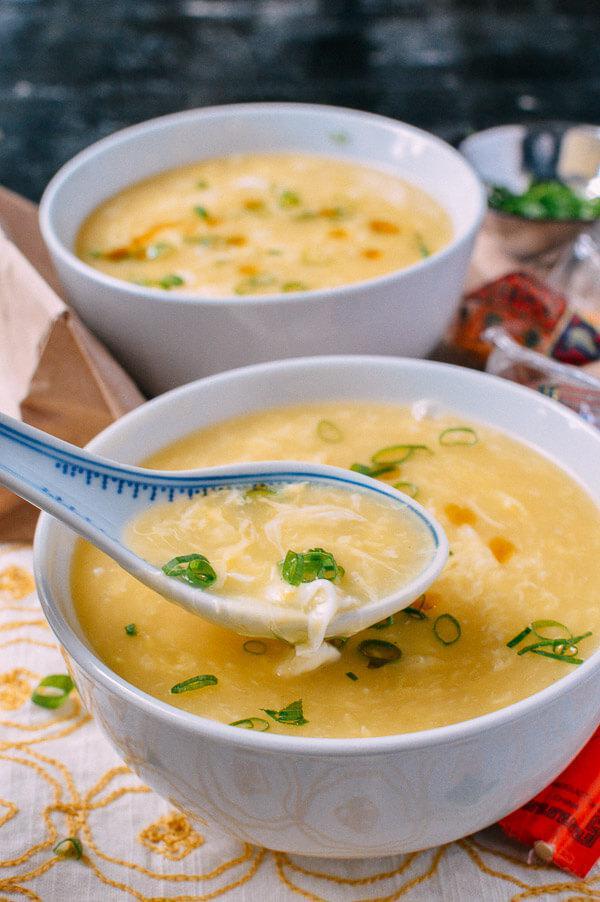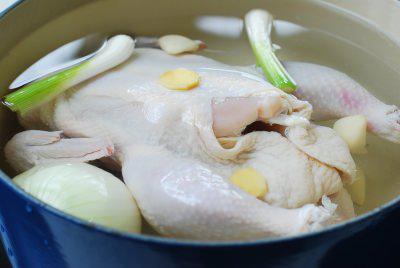The first image is the image on the left, the second image is the image on the right. Given the left and right images, does the statement "A metal spoon is over a round container of broth and other ingredients in one image." hold true? Answer yes or no. No. The first image is the image on the left, the second image is the image on the right. For the images displayed, is the sentence "There is a single white bowl in the left image." factually correct? Answer yes or no. No. 